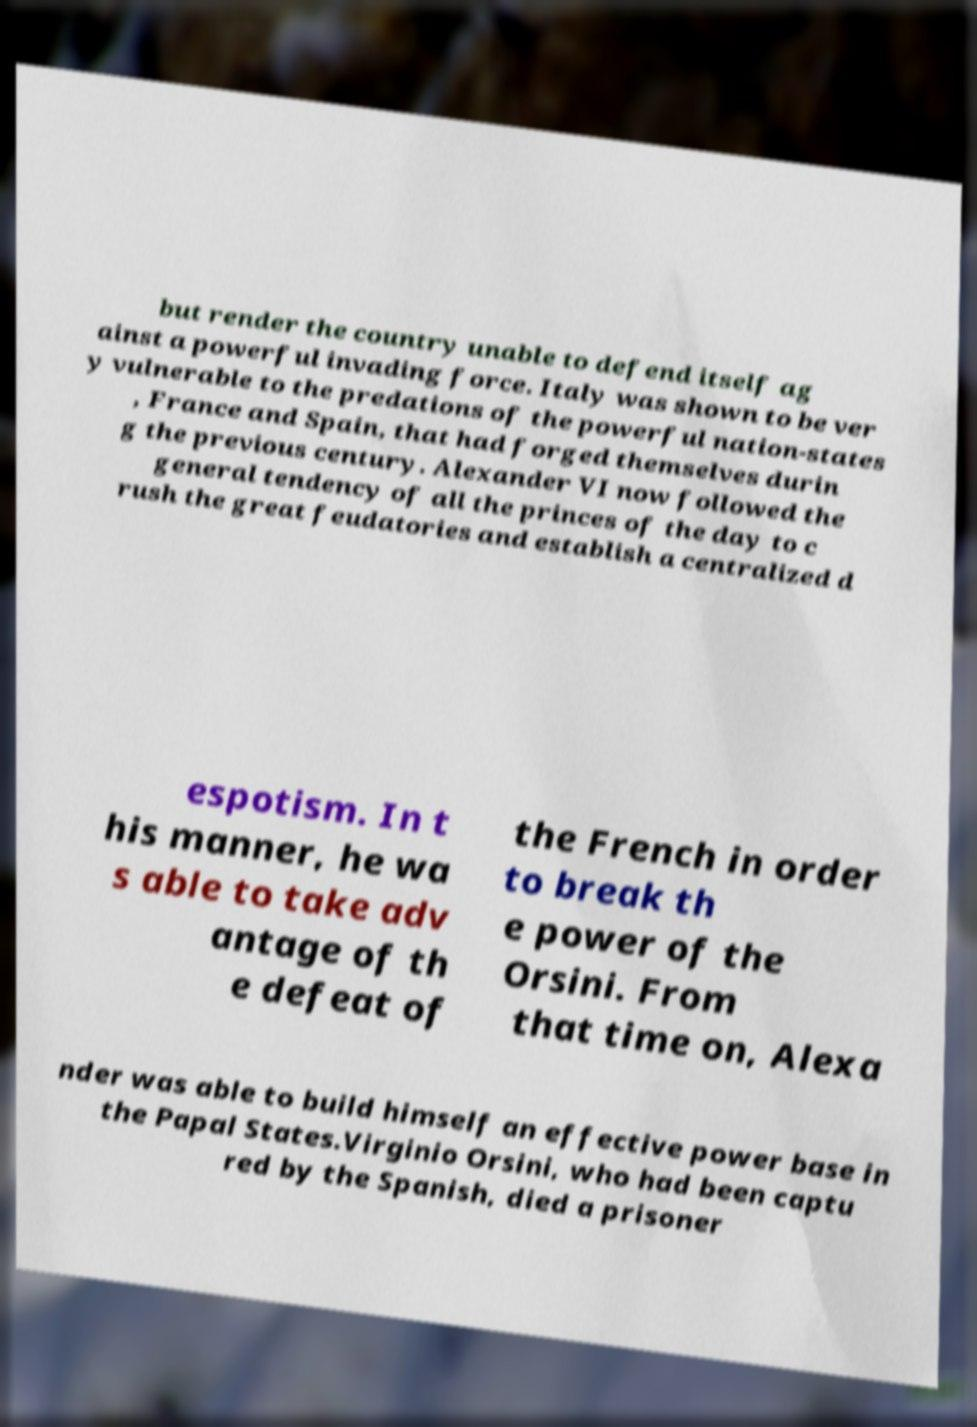What messages or text are displayed in this image? I need them in a readable, typed format. but render the country unable to defend itself ag ainst a powerful invading force. Italy was shown to be ver y vulnerable to the predations of the powerful nation-states , France and Spain, that had forged themselves durin g the previous century. Alexander VI now followed the general tendency of all the princes of the day to c rush the great feudatories and establish a centralized d espotism. In t his manner, he wa s able to take adv antage of th e defeat of the French in order to break th e power of the Orsini. From that time on, Alexa nder was able to build himself an effective power base in the Papal States.Virginio Orsini, who had been captu red by the Spanish, died a prisoner 